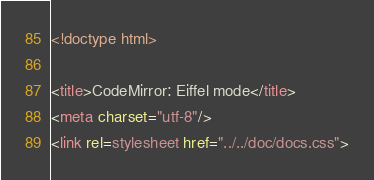<code> <loc_0><loc_0><loc_500><loc_500><_HTML_><!doctype html>

<title>CodeMirror: Eiffel mode</title>
<meta charset="utf-8"/>
<link rel=stylesheet href="../../doc/docs.css">
</code> 